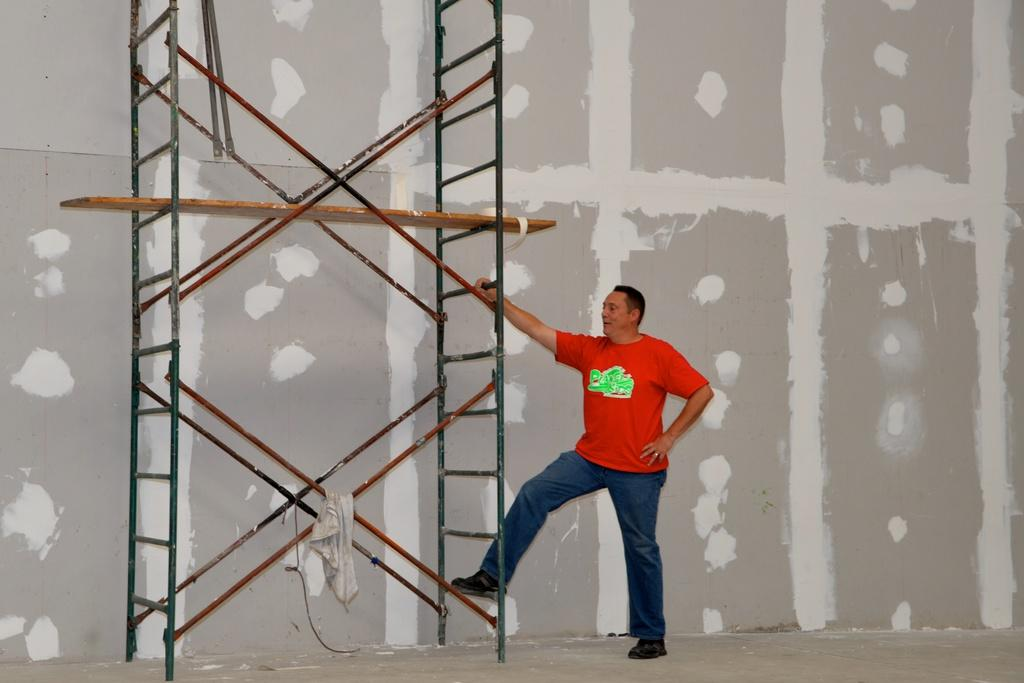What is located in the foreground of the image? There is a man and a bamboo structure in the foreground of the image. What is on the bamboo structure? There is a cloth on the bamboo structure. What can be seen in the background of the image? There appears to be a wall in the background of the image. What type of boundary is visible in the image? There is no boundary visible in the image; it features a man, a bamboo structure, and a wall in the background. 